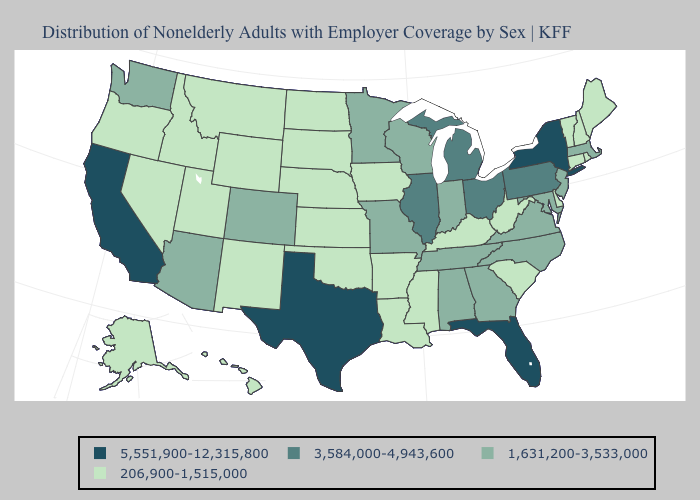Name the states that have a value in the range 206,900-1,515,000?
Answer briefly. Alaska, Arkansas, Connecticut, Delaware, Hawaii, Idaho, Iowa, Kansas, Kentucky, Louisiana, Maine, Mississippi, Montana, Nebraska, Nevada, New Hampshire, New Mexico, North Dakota, Oklahoma, Oregon, Rhode Island, South Carolina, South Dakota, Utah, Vermont, West Virginia, Wyoming. Which states hav the highest value in the West?
Write a very short answer. California. Does Nevada have the highest value in the West?
Quick response, please. No. Name the states that have a value in the range 5,551,900-12,315,800?
Write a very short answer. California, Florida, New York, Texas. Name the states that have a value in the range 5,551,900-12,315,800?
Answer briefly. California, Florida, New York, Texas. Among the states that border New York , which have the highest value?
Give a very brief answer. Pennsylvania. How many symbols are there in the legend?
Keep it brief. 4. Among the states that border Louisiana , does Texas have the lowest value?
Keep it brief. No. What is the highest value in the USA?
Keep it brief. 5,551,900-12,315,800. Does the first symbol in the legend represent the smallest category?
Short answer required. No. Does the map have missing data?
Keep it brief. No. Name the states that have a value in the range 5,551,900-12,315,800?
Answer briefly. California, Florida, New York, Texas. Does the map have missing data?
Give a very brief answer. No. Name the states that have a value in the range 1,631,200-3,533,000?
Be succinct. Alabama, Arizona, Colorado, Georgia, Indiana, Maryland, Massachusetts, Minnesota, Missouri, New Jersey, North Carolina, Tennessee, Virginia, Washington, Wisconsin. Name the states that have a value in the range 206,900-1,515,000?
Keep it brief. Alaska, Arkansas, Connecticut, Delaware, Hawaii, Idaho, Iowa, Kansas, Kentucky, Louisiana, Maine, Mississippi, Montana, Nebraska, Nevada, New Hampshire, New Mexico, North Dakota, Oklahoma, Oregon, Rhode Island, South Carolina, South Dakota, Utah, Vermont, West Virginia, Wyoming. 